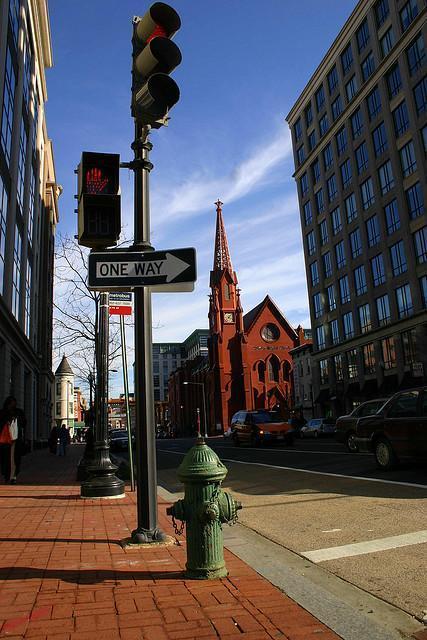How many traffic lights can be seen?
Give a very brief answer. 2. How many giraffes are there?
Give a very brief answer. 0. 